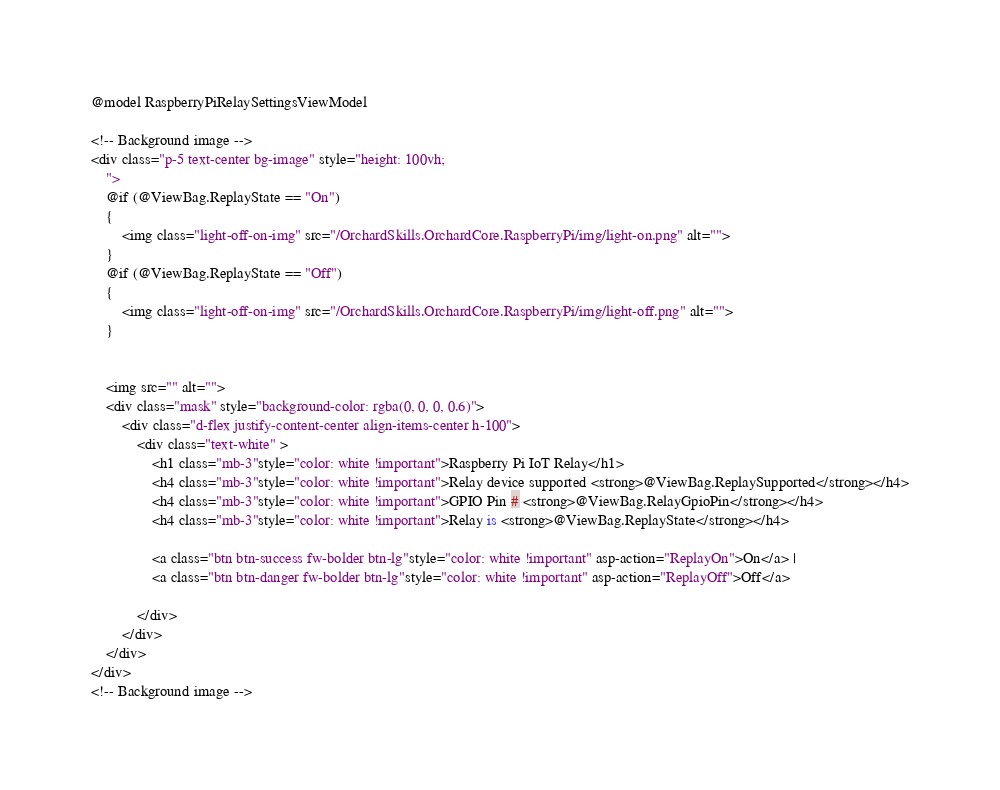Convert code to text. <code><loc_0><loc_0><loc_500><loc_500><_C#_>@model RaspberryPiRelaySettingsViewModel

<!-- Background image -->
<div class="p-5 text-center bg-image" style="height: 100vh;
    ">
    @if (@ViewBag.ReplayState == "On")
    {
        <img class="light-off-on-img" src="/OrchardSkills.OrchardCore.RaspberryPi/img/light-on.png" alt="">
    }
    @if (@ViewBag.ReplayState == "Off")
    {
        <img class="light-off-on-img" src="/OrchardSkills.OrchardCore.RaspberryPi/img/light-off.png" alt="">
    }


    <img src="" alt="">
    <div class="mask" style="background-color: rgba(0, 0, 0, 0.6)">
        <div class="d-flex justify-content-center align-items-center h-100">
            <div class="text-white" >
                <h1 class="mb-3"style="color: white !important">Raspberry Pi IoT Relay</h1>
                <h4 class="mb-3"style="color: white !important">Relay device supported <strong>@ViewBag.ReplaySupported</strong></h4>
                <h4 class="mb-3"style="color: white !important">GPIO Pin # <strong>@ViewBag.RelayGpioPin</strong></h4>
                <h4 class="mb-3"style="color: white !important">Relay is <strong>@ViewBag.ReplayState</strong></h4>

                <a class="btn btn-success fw-bolder btn-lg"style="color: white !important" asp-action="ReplayOn">On</a> |
                <a class="btn btn-danger fw-bolder btn-lg"style="color: white !important" asp-action="ReplayOff">Off</a>

            </div>
        </div>
    </div>
</div>
<!-- Background image --></code> 